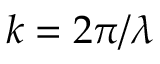Convert formula to latex. <formula><loc_0><loc_0><loc_500><loc_500>k = 2 \pi / \lambda</formula> 